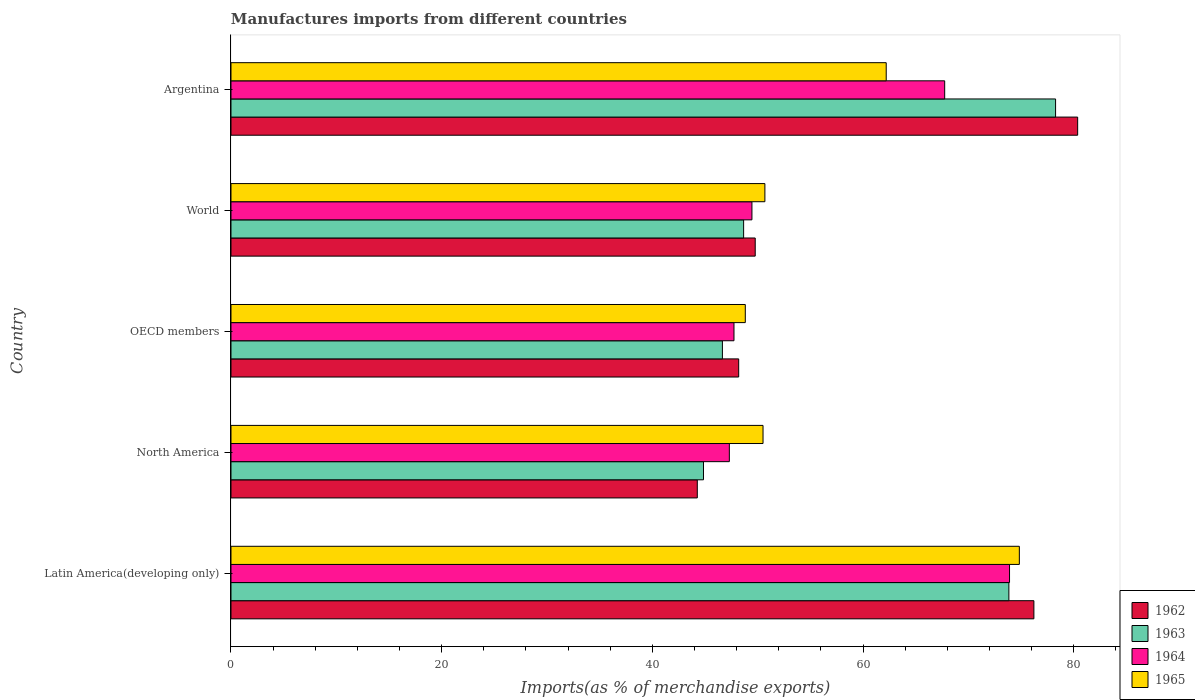How many different coloured bars are there?
Provide a short and direct response. 4. How many groups of bars are there?
Keep it short and to the point. 5. Are the number of bars per tick equal to the number of legend labels?
Your answer should be very brief. Yes. What is the label of the 2nd group of bars from the top?
Your answer should be compact. World. In how many cases, is the number of bars for a given country not equal to the number of legend labels?
Ensure brevity in your answer.  0. What is the percentage of imports to different countries in 1963 in North America?
Keep it short and to the point. 44.85. Across all countries, what is the maximum percentage of imports to different countries in 1964?
Your answer should be compact. 73.9. Across all countries, what is the minimum percentage of imports to different countries in 1962?
Your answer should be compact. 44.26. In which country was the percentage of imports to different countries in 1965 maximum?
Provide a succinct answer. Latin America(developing only). In which country was the percentage of imports to different countries in 1962 minimum?
Your response must be concise. North America. What is the total percentage of imports to different countries in 1964 in the graph?
Offer a terse response. 286.14. What is the difference between the percentage of imports to different countries in 1964 in Argentina and that in Latin America(developing only)?
Provide a short and direct response. -6.16. What is the difference between the percentage of imports to different countries in 1964 in Latin America(developing only) and the percentage of imports to different countries in 1962 in World?
Your answer should be compact. 24.14. What is the average percentage of imports to different countries in 1963 per country?
Keep it short and to the point. 58.45. What is the difference between the percentage of imports to different countries in 1965 and percentage of imports to different countries in 1964 in Latin America(developing only)?
Give a very brief answer. 0.93. What is the ratio of the percentage of imports to different countries in 1962 in Argentina to that in North America?
Offer a very short reply. 1.82. Is the difference between the percentage of imports to different countries in 1965 in Argentina and OECD members greater than the difference between the percentage of imports to different countries in 1964 in Argentina and OECD members?
Provide a succinct answer. No. What is the difference between the highest and the second highest percentage of imports to different countries in 1964?
Make the answer very short. 6.16. What is the difference between the highest and the lowest percentage of imports to different countries in 1962?
Offer a very short reply. 36.1. Is it the case that in every country, the sum of the percentage of imports to different countries in 1965 and percentage of imports to different countries in 1964 is greater than the sum of percentage of imports to different countries in 1962 and percentage of imports to different countries in 1963?
Your answer should be compact. No. What does the 4th bar from the top in North America represents?
Your response must be concise. 1962. What does the 2nd bar from the bottom in Latin America(developing only) represents?
Your answer should be compact. 1963. Are the values on the major ticks of X-axis written in scientific E-notation?
Keep it short and to the point. No. Does the graph contain grids?
Your answer should be compact. No. How are the legend labels stacked?
Your answer should be compact. Vertical. What is the title of the graph?
Offer a terse response. Manufactures imports from different countries. What is the label or title of the X-axis?
Give a very brief answer. Imports(as % of merchandise exports). What is the Imports(as % of merchandise exports) of 1962 in Latin America(developing only)?
Offer a very short reply. 76.21. What is the Imports(as % of merchandise exports) in 1963 in Latin America(developing only)?
Your answer should be compact. 73.84. What is the Imports(as % of merchandise exports) in 1964 in Latin America(developing only)?
Offer a very short reply. 73.9. What is the Imports(as % of merchandise exports) in 1965 in Latin America(developing only)?
Provide a succinct answer. 74.83. What is the Imports(as % of merchandise exports) of 1962 in North America?
Your answer should be compact. 44.26. What is the Imports(as % of merchandise exports) of 1963 in North America?
Provide a succinct answer. 44.85. What is the Imports(as % of merchandise exports) of 1964 in North America?
Keep it short and to the point. 47.3. What is the Imports(as % of merchandise exports) of 1965 in North America?
Give a very brief answer. 50.5. What is the Imports(as % of merchandise exports) in 1962 in OECD members?
Give a very brief answer. 48.19. What is the Imports(as % of merchandise exports) of 1963 in OECD members?
Provide a succinct answer. 46.65. What is the Imports(as % of merchandise exports) in 1964 in OECD members?
Make the answer very short. 47.75. What is the Imports(as % of merchandise exports) in 1965 in OECD members?
Your answer should be very brief. 48.82. What is the Imports(as % of merchandise exports) of 1962 in World?
Ensure brevity in your answer.  49.76. What is the Imports(as % of merchandise exports) of 1963 in World?
Keep it short and to the point. 48.66. What is the Imports(as % of merchandise exports) in 1964 in World?
Provide a succinct answer. 49.45. What is the Imports(as % of merchandise exports) in 1965 in World?
Your answer should be compact. 50.68. What is the Imports(as % of merchandise exports) in 1962 in Argentina?
Ensure brevity in your answer.  80.37. What is the Imports(as % of merchandise exports) in 1963 in Argentina?
Offer a terse response. 78.27. What is the Imports(as % of merchandise exports) of 1964 in Argentina?
Ensure brevity in your answer.  67.75. What is the Imports(as % of merchandise exports) of 1965 in Argentina?
Provide a succinct answer. 62.19. Across all countries, what is the maximum Imports(as % of merchandise exports) in 1962?
Provide a short and direct response. 80.37. Across all countries, what is the maximum Imports(as % of merchandise exports) in 1963?
Offer a terse response. 78.27. Across all countries, what is the maximum Imports(as % of merchandise exports) in 1964?
Your answer should be compact. 73.9. Across all countries, what is the maximum Imports(as % of merchandise exports) in 1965?
Your answer should be very brief. 74.83. Across all countries, what is the minimum Imports(as % of merchandise exports) in 1962?
Make the answer very short. 44.26. Across all countries, what is the minimum Imports(as % of merchandise exports) in 1963?
Your answer should be compact. 44.85. Across all countries, what is the minimum Imports(as % of merchandise exports) in 1964?
Your answer should be very brief. 47.3. Across all countries, what is the minimum Imports(as % of merchandise exports) in 1965?
Make the answer very short. 48.82. What is the total Imports(as % of merchandise exports) of 1962 in the graph?
Your answer should be compact. 298.79. What is the total Imports(as % of merchandise exports) of 1963 in the graph?
Your answer should be very brief. 292.26. What is the total Imports(as % of merchandise exports) in 1964 in the graph?
Your answer should be very brief. 286.14. What is the total Imports(as % of merchandise exports) in 1965 in the graph?
Your response must be concise. 287.03. What is the difference between the Imports(as % of merchandise exports) in 1962 in Latin America(developing only) and that in North America?
Offer a very short reply. 31.95. What is the difference between the Imports(as % of merchandise exports) in 1963 in Latin America(developing only) and that in North America?
Ensure brevity in your answer.  28.99. What is the difference between the Imports(as % of merchandise exports) in 1964 in Latin America(developing only) and that in North America?
Provide a short and direct response. 26.6. What is the difference between the Imports(as % of merchandise exports) in 1965 in Latin America(developing only) and that in North America?
Offer a terse response. 24.33. What is the difference between the Imports(as % of merchandise exports) in 1962 in Latin America(developing only) and that in OECD members?
Your answer should be very brief. 28.02. What is the difference between the Imports(as % of merchandise exports) of 1963 in Latin America(developing only) and that in OECD members?
Your response must be concise. 27.19. What is the difference between the Imports(as % of merchandise exports) in 1964 in Latin America(developing only) and that in OECD members?
Offer a very short reply. 26.16. What is the difference between the Imports(as % of merchandise exports) of 1965 in Latin America(developing only) and that in OECD members?
Ensure brevity in your answer.  26.01. What is the difference between the Imports(as % of merchandise exports) of 1962 in Latin America(developing only) and that in World?
Your response must be concise. 26.45. What is the difference between the Imports(as % of merchandise exports) of 1963 in Latin America(developing only) and that in World?
Ensure brevity in your answer.  25.18. What is the difference between the Imports(as % of merchandise exports) of 1964 in Latin America(developing only) and that in World?
Provide a short and direct response. 24.45. What is the difference between the Imports(as % of merchandise exports) in 1965 in Latin America(developing only) and that in World?
Provide a short and direct response. 24.15. What is the difference between the Imports(as % of merchandise exports) in 1962 in Latin America(developing only) and that in Argentina?
Provide a short and direct response. -4.15. What is the difference between the Imports(as % of merchandise exports) in 1963 in Latin America(developing only) and that in Argentina?
Provide a short and direct response. -4.43. What is the difference between the Imports(as % of merchandise exports) of 1964 in Latin America(developing only) and that in Argentina?
Make the answer very short. 6.16. What is the difference between the Imports(as % of merchandise exports) in 1965 in Latin America(developing only) and that in Argentina?
Keep it short and to the point. 12.64. What is the difference between the Imports(as % of merchandise exports) of 1962 in North America and that in OECD members?
Make the answer very short. -3.93. What is the difference between the Imports(as % of merchandise exports) in 1963 in North America and that in OECD members?
Make the answer very short. -1.8. What is the difference between the Imports(as % of merchandise exports) in 1964 in North America and that in OECD members?
Give a very brief answer. -0.44. What is the difference between the Imports(as % of merchandise exports) of 1965 in North America and that in OECD members?
Keep it short and to the point. 1.68. What is the difference between the Imports(as % of merchandise exports) of 1962 in North America and that in World?
Keep it short and to the point. -5.5. What is the difference between the Imports(as % of merchandise exports) in 1963 in North America and that in World?
Provide a succinct answer. -3.81. What is the difference between the Imports(as % of merchandise exports) in 1964 in North America and that in World?
Provide a succinct answer. -2.14. What is the difference between the Imports(as % of merchandise exports) of 1965 in North America and that in World?
Your answer should be very brief. -0.18. What is the difference between the Imports(as % of merchandise exports) of 1962 in North America and that in Argentina?
Your answer should be very brief. -36.1. What is the difference between the Imports(as % of merchandise exports) in 1963 in North America and that in Argentina?
Keep it short and to the point. -33.42. What is the difference between the Imports(as % of merchandise exports) in 1964 in North America and that in Argentina?
Give a very brief answer. -20.44. What is the difference between the Imports(as % of merchandise exports) in 1965 in North America and that in Argentina?
Provide a succinct answer. -11.69. What is the difference between the Imports(as % of merchandise exports) in 1962 in OECD members and that in World?
Your answer should be compact. -1.57. What is the difference between the Imports(as % of merchandise exports) in 1963 in OECD members and that in World?
Make the answer very short. -2.01. What is the difference between the Imports(as % of merchandise exports) of 1964 in OECD members and that in World?
Keep it short and to the point. -1.7. What is the difference between the Imports(as % of merchandise exports) in 1965 in OECD members and that in World?
Your answer should be compact. -1.86. What is the difference between the Imports(as % of merchandise exports) in 1962 in OECD members and that in Argentina?
Your answer should be compact. -32.17. What is the difference between the Imports(as % of merchandise exports) of 1963 in OECD members and that in Argentina?
Your response must be concise. -31.62. What is the difference between the Imports(as % of merchandise exports) in 1964 in OECD members and that in Argentina?
Provide a succinct answer. -20. What is the difference between the Imports(as % of merchandise exports) in 1965 in OECD members and that in Argentina?
Keep it short and to the point. -13.38. What is the difference between the Imports(as % of merchandise exports) in 1962 in World and that in Argentina?
Your answer should be compact. -30.61. What is the difference between the Imports(as % of merchandise exports) of 1963 in World and that in Argentina?
Offer a very short reply. -29.61. What is the difference between the Imports(as % of merchandise exports) of 1964 in World and that in Argentina?
Provide a succinct answer. -18.3. What is the difference between the Imports(as % of merchandise exports) in 1965 in World and that in Argentina?
Ensure brevity in your answer.  -11.52. What is the difference between the Imports(as % of merchandise exports) in 1962 in Latin America(developing only) and the Imports(as % of merchandise exports) in 1963 in North America?
Provide a succinct answer. 31.36. What is the difference between the Imports(as % of merchandise exports) in 1962 in Latin America(developing only) and the Imports(as % of merchandise exports) in 1964 in North America?
Offer a very short reply. 28.91. What is the difference between the Imports(as % of merchandise exports) in 1962 in Latin America(developing only) and the Imports(as % of merchandise exports) in 1965 in North America?
Provide a succinct answer. 25.71. What is the difference between the Imports(as % of merchandise exports) in 1963 in Latin America(developing only) and the Imports(as % of merchandise exports) in 1964 in North America?
Make the answer very short. 26.53. What is the difference between the Imports(as % of merchandise exports) of 1963 in Latin America(developing only) and the Imports(as % of merchandise exports) of 1965 in North America?
Ensure brevity in your answer.  23.34. What is the difference between the Imports(as % of merchandise exports) in 1964 in Latin America(developing only) and the Imports(as % of merchandise exports) in 1965 in North America?
Offer a very short reply. 23.4. What is the difference between the Imports(as % of merchandise exports) in 1962 in Latin America(developing only) and the Imports(as % of merchandise exports) in 1963 in OECD members?
Your answer should be very brief. 29.57. What is the difference between the Imports(as % of merchandise exports) in 1962 in Latin America(developing only) and the Imports(as % of merchandise exports) in 1964 in OECD members?
Give a very brief answer. 28.47. What is the difference between the Imports(as % of merchandise exports) in 1962 in Latin America(developing only) and the Imports(as % of merchandise exports) in 1965 in OECD members?
Ensure brevity in your answer.  27.39. What is the difference between the Imports(as % of merchandise exports) in 1963 in Latin America(developing only) and the Imports(as % of merchandise exports) in 1964 in OECD members?
Offer a very short reply. 26.09. What is the difference between the Imports(as % of merchandise exports) in 1963 in Latin America(developing only) and the Imports(as % of merchandise exports) in 1965 in OECD members?
Make the answer very short. 25.02. What is the difference between the Imports(as % of merchandise exports) in 1964 in Latin America(developing only) and the Imports(as % of merchandise exports) in 1965 in OECD members?
Keep it short and to the point. 25.08. What is the difference between the Imports(as % of merchandise exports) of 1962 in Latin America(developing only) and the Imports(as % of merchandise exports) of 1963 in World?
Your answer should be compact. 27.55. What is the difference between the Imports(as % of merchandise exports) in 1962 in Latin America(developing only) and the Imports(as % of merchandise exports) in 1964 in World?
Offer a very short reply. 26.76. What is the difference between the Imports(as % of merchandise exports) of 1962 in Latin America(developing only) and the Imports(as % of merchandise exports) of 1965 in World?
Provide a succinct answer. 25.53. What is the difference between the Imports(as % of merchandise exports) of 1963 in Latin America(developing only) and the Imports(as % of merchandise exports) of 1964 in World?
Give a very brief answer. 24.39. What is the difference between the Imports(as % of merchandise exports) of 1963 in Latin America(developing only) and the Imports(as % of merchandise exports) of 1965 in World?
Make the answer very short. 23.16. What is the difference between the Imports(as % of merchandise exports) of 1964 in Latin America(developing only) and the Imports(as % of merchandise exports) of 1965 in World?
Ensure brevity in your answer.  23.22. What is the difference between the Imports(as % of merchandise exports) in 1962 in Latin America(developing only) and the Imports(as % of merchandise exports) in 1963 in Argentina?
Provide a succinct answer. -2.06. What is the difference between the Imports(as % of merchandise exports) in 1962 in Latin America(developing only) and the Imports(as % of merchandise exports) in 1964 in Argentina?
Your response must be concise. 8.47. What is the difference between the Imports(as % of merchandise exports) in 1962 in Latin America(developing only) and the Imports(as % of merchandise exports) in 1965 in Argentina?
Offer a very short reply. 14.02. What is the difference between the Imports(as % of merchandise exports) in 1963 in Latin America(developing only) and the Imports(as % of merchandise exports) in 1964 in Argentina?
Provide a succinct answer. 6.09. What is the difference between the Imports(as % of merchandise exports) in 1963 in Latin America(developing only) and the Imports(as % of merchandise exports) in 1965 in Argentina?
Offer a very short reply. 11.64. What is the difference between the Imports(as % of merchandise exports) in 1964 in Latin America(developing only) and the Imports(as % of merchandise exports) in 1965 in Argentina?
Provide a succinct answer. 11.71. What is the difference between the Imports(as % of merchandise exports) in 1962 in North America and the Imports(as % of merchandise exports) in 1963 in OECD members?
Make the answer very short. -2.38. What is the difference between the Imports(as % of merchandise exports) in 1962 in North America and the Imports(as % of merchandise exports) in 1964 in OECD members?
Give a very brief answer. -3.48. What is the difference between the Imports(as % of merchandise exports) of 1962 in North America and the Imports(as % of merchandise exports) of 1965 in OECD members?
Your answer should be very brief. -4.56. What is the difference between the Imports(as % of merchandise exports) in 1963 in North America and the Imports(as % of merchandise exports) in 1964 in OECD members?
Provide a short and direct response. -2.89. What is the difference between the Imports(as % of merchandise exports) in 1963 in North America and the Imports(as % of merchandise exports) in 1965 in OECD members?
Offer a very short reply. -3.97. What is the difference between the Imports(as % of merchandise exports) of 1964 in North America and the Imports(as % of merchandise exports) of 1965 in OECD members?
Provide a short and direct response. -1.52. What is the difference between the Imports(as % of merchandise exports) of 1962 in North America and the Imports(as % of merchandise exports) of 1963 in World?
Provide a short and direct response. -4.4. What is the difference between the Imports(as % of merchandise exports) in 1962 in North America and the Imports(as % of merchandise exports) in 1964 in World?
Provide a short and direct response. -5.19. What is the difference between the Imports(as % of merchandise exports) in 1962 in North America and the Imports(as % of merchandise exports) in 1965 in World?
Make the answer very short. -6.42. What is the difference between the Imports(as % of merchandise exports) of 1963 in North America and the Imports(as % of merchandise exports) of 1964 in World?
Make the answer very short. -4.6. What is the difference between the Imports(as % of merchandise exports) in 1963 in North America and the Imports(as % of merchandise exports) in 1965 in World?
Offer a terse response. -5.83. What is the difference between the Imports(as % of merchandise exports) in 1964 in North America and the Imports(as % of merchandise exports) in 1965 in World?
Offer a very short reply. -3.37. What is the difference between the Imports(as % of merchandise exports) of 1962 in North America and the Imports(as % of merchandise exports) of 1963 in Argentina?
Ensure brevity in your answer.  -34.01. What is the difference between the Imports(as % of merchandise exports) of 1962 in North America and the Imports(as % of merchandise exports) of 1964 in Argentina?
Provide a succinct answer. -23.48. What is the difference between the Imports(as % of merchandise exports) in 1962 in North America and the Imports(as % of merchandise exports) in 1965 in Argentina?
Your answer should be compact. -17.93. What is the difference between the Imports(as % of merchandise exports) in 1963 in North America and the Imports(as % of merchandise exports) in 1964 in Argentina?
Offer a terse response. -22.89. What is the difference between the Imports(as % of merchandise exports) of 1963 in North America and the Imports(as % of merchandise exports) of 1965 in Argentina?
Your response must be concise. -17.34. What is the difference between the Imports(as % of merchandise exports) of 1964 in North America and the Imports(as % of merchandise exports) of 1965 in Argentina?
Give a very brief answer. -14.89. What is the difference between the Imports(as % of merchandise exports) of 1962 in OECD members and the Imports(as % of merchandise exports) of 1963 in World?
Make the answer very short. -0.47. What is the difference between the Imports(as % of merchandise exports) in 1962 in OECD members and the Imports(as % of merchandise exports) in 1964 in World?
Make the answer very short. -1.26. What is the difference between the Imports(as % of merchandise exports) of 1962 in OECD members and the Imports(as % of merchandise exports) of 1965 in World?
Your answer should be compact. -2.49. What is the difference between the Imports(as % of merchandise exports) of 1963 in OECD members and the Imports(as % of merchandise exports) of 1964 in World?
Offer a terse response. -2.8. What is the difference between the Imports(as % of merchandise exports) of 1963 in OECD members and the Imports(as % of merchandise exports) of 1965 in World?
Keep it short and to the point. -4.03. What is the difference between the Imports(as % of merchandise exports) in 1964 in OECD members and the Imports(as % of merchandise exports) in 1965 in World?
Ensure brevity in your answer.  -2.93. What is the difference between the Imports(as % of merchandise exports) of 1962 in OECD members and the Imports(as % of merchandise exports) of 1963 in Argentina?
Ensure brevity in your answer.  -30.08. What is the difference between the Imports(as % of merchandise exports) in 1962 in OECD members and the Imports(as % of merchandise exports) in 1964 in Argentina?
Provide a short and direct response. -19.55. What is the difference between the Imports(as % of merchandise exports) of 1962 in OECD members and the Imports(as % of merchandise exports) of 1965 in Argentina?
Offer a terse response. -14. What is the difference between the Imports(as % of merchandise exports) in 1963 in OECD members and the Imports(as % of merchandise exports) in 1964 in Argentina?
Offer a very short reply. -21.1. What is the difference between the Imports(as % of merchandise exports) in 1963 in OECD members and the Imports(as % of merchandise exports) in 1965 in Argentina?
Provide a succinct answer. -15.55. What is the difference between the Imports(as % of merchandise exports) of 1964 in OECD members and the Imports(as % of merchandise exports) of 1965 in Argentina?
Your answer should be very brief. -14.45. What is the difference between the Imports(as % of merchandise exports) in 1962 in World and the Imports(as % of merchandise exports) in 1963 in Argentina?
Your response must be concise. -28.51. What is the difference between the Imports(as % of merchandise exports) of 1962 in World and the Imports(as % of merchandise exports) of 1964 in Argentina?
Your response must be concise. -17.98. What is the difference between the Imports(as % of merchandise exports) in 1962 in World and the Imports(as % of merchandise exports) in 1965 in Argentina?
Keep it short and to the point. -12.43. What is the difference between the Imports(as % of merchandise exports) of 1963 in World and the Imports(as % of merchandise exports) of 1964 in Argentina?
Make the answer very short. -19.09. What is the difference between the Imports(as % of merchandise exports) of 1963 in World and the Imports(as % of merchandise exports) of 1965 in Argentina?
Offer a very short reply. -13.54. What is the difference between the Imports(as % of merchandise exports) of 1964 in World and the Imports(as % of merchandise exports) of 1965 in Argentina?
Provide a succinct answer. -12.75. What is the average Imports(as % of merchandise exports) of 1962 per country?
Your response must be concise. 59.76. What is the average Imports(as % of merchandise exports) in 1963 per country?
Your response must be concise. 58.45. What is the average Imports(as % of merchandise exports) of 1964 per country?
Your response must be concise. 57.23. What is the average Imports(as % of merchandise exports) of 1965 per country?
Ensure brevity in your answer.  57.41. What is the difference between the Imports(as % of merchandise exports) in 1962 and Imports(as % of merchandise exports) in 1963 in Latin America(developing only)?
Make the answer very short. 2.37. What is the difference between the Imports(as % of merchandise exports) of 1962 and Imports(as % of merchandise exports) of 1964 in Latin America(developing only)?
Provide a succinct answer. 2.31. What is the difference between the Imports(as % of merchandise exports) in 1962 and Imports(as % of merchandise exports) in 1965 in Latin America(developing only)?
Ensure brevity in your answer.  1.38. What is the difference between the Imports(as % of merchandise exports) in 1963 and Imports(as % of merchandise exports) in 1964 in Latin America(developing only)?
Ensure brevity in your answer.  -0.06. What is the difference between the Imports(as % of merchandise exports) in 1963 and Imports(as % of merchandise exports) in 1965 in Latin America(developing only)?
Keep it short and to the point. -0.99. What is the difference between the Imports(as % of merchandise exports) of 1964 and Imports(as % of merchandise exports) of 1965 in Latin America(developing only)?
Ensure brevity in your answer.  -0.93. What is the difference between the Imports(as % of merchandise exports) of 1962 and Imports(as % of merchandise exports) of 1963 in North America?
Give a very brief answer. -0.59. What is the difference between the Imports(as % of merchandise exports) in 1962 and Imports(as % of merchandise exports) in 1964 in North America?
Give a very brief answer. -3.04. What is the difference between the Imports(as % of merchandise exports) of 1962 and Imports(as % of merchandise exports) of 1965 in North America?
Keep it short and to the point. -6.24. What is the difference between the Imports(as % of merchandise exports) of 1963 and Imports(as % of merchandise exports) of 1964 in North America?
Give a very brief answer. -2.45. What is the difference between the Imports(as % of merchandise exports) of 1963 and Imports(as % of merchandise exports) of 1965 in North America?
Offer a terse response. -5.65. What is the difference between the Imports(as % of merchandise exports) of 1964 and Imports(as % of merchandise exports) of 1965 in North America?
Provide a succinct answer. -3.2. What is the difference between the Imports(as % of merchandise exports) of 1962 and Imports(as % of merchandise exports) of 1963 in OECD members?
Your response must be concise. 1.55. What is the difference between the Imports(as % of merchandise exports) in 1962 and Imports(as % of merchandise exports) in 1964 in OECD members?
Provide a short and direct response. 0.45. What is the difference between the Imports(as % of merchandise exports) of 1962 and Imports(as % of merchandise exports) of 1965 in OECD members?
Make the answer very short. -0.63. What is the difference between the Imports(as % of merchandise exports) of 1963 and Imports(as % of merchandise exports) of 1964 in OECD members?
Provide a succinct answer. -1.1. What is the difference between the Imports(as % of merchandise exports) in 1963 and Imports(as % of merchandise exports) in 1965 in OECD members?
Ensure brevity in your answer.  -2.17. What is the difference between the Imports(as % of merchandise exports) of 1964 and Imports(as % of merchandise exports) of 1965 in OECD members?
Provide a succinct answer. -1.07. What is the difference between the Imports(as % of merchandise exports) of 1962 and Imports(as % of merchandise exports) of 1963 in World?
Give a very brief answer. 1.1. What is the difference between the Imports(as % of merchandise exports) of 1962 and Imports(as % of merchandise exports) of 1964 in World?
Make the answer very short. 0.31. What is the difference between the Imports(as % of merchandise exports) in 1962 and Imports(as % of merchandise exports) in 1965 in World?
Your answer should be very brief. -0.92. What is the difference between the Imports(as % of merchandise exports) in 1963 and Imports(as % of merchandise exports) in 1964 in World?
Provide a succinct answer. -0.79. What is the difference between the Imports(as % of merchandise exports) of 1963 and Imports(as % of merchandise exports) of 1965 in World?
Your response must be concise. -2.02. What is the difference between the Imports(as % of merchandise exports) of 1964 and Imports(as % of merchandise exports) of 1965 in World?
Keep it short and to the point. -1.23. What is the difference between the Imports(as % of merchandise exports) in 1962 and Imports(as % of merchandise exports) in 1963 in Argentina?
Offer a very short reply. 2.1. What is the difference between the Imports(as % of merchandise exports) in 1962 and Imports(as % of merchandise exports) in 1964 in Argentina?
Give a very brief answer. 12.62. What is the difference between the Imports(as % of merchandise exports) of 1962 and Imports(as % of merchandise exports) of 1965 in Argentina?
Provide a succinct answer. 18.17. What is the difference between the Imports(as % of merchandise exports) of 1963 and Imports(as % of merchandise exports) of 1964 in Argentina?
Give a very brief answer. 10.52. What is the difference between the Imports(as % of merchandise exports) of 1963 and Imports(as % of merchandise exports) of 1965 in Argentina?
Your answer should be compact. 16.08. What is the difference between the Imports(as % of merchandise exports) in 1964 and Imports(as % of merchandise exports) in 1965 in Argentina?
Offer a terse response. 5.55. What is the ratio of the Imports(as % of merchandise exports) in 1962 in Latin America(developing only) to that in North America?
Make the answer very short. 1.72. What is the ratio of the Imports(as % of merchandise exports) in 1963 in Latin America(developing only) to that in North America?
Give a very brief answer. 1.65. What is the ratio of the Imports(as % of merchandise exports) in 1964 in Latin America(developing only) to that in North America?
Provide a short and direct response. 1.56. What is the ratio of the Imports(as % of merchandise exports) of 1965 in Latin America(developing only) to that in North America?
Ensure brevity in your answer.  1.48. What is the ratio of the Imports(as % of merchandise exports) of 1962 in Latin America(developing only) to that in OECD members?
Your response must be concise. 1.58. What is the ratio of the Imports(as % of merchandise exports) in 1963 in Latin America(developing only) to that in OECD members?
Provide a succinct answer. 1.58. What is the ratio of the Imports(as % of merchandise exports) in 1964 in Latin America(developing only) to that in OECD members?
Keep it short and to the point. 1.55. What is the ratio of the Imports(as % of merchandise exports) in 1965 in Latin America(developing only) to that in OECD members?
Keep it short and to the point. 1.53. What is the ratio of the Imports(as % of merchandise exports) in 1962 in Latin America(developing only) to that in World?
Ensure brevity in your answer.  1.53. What is the ratio of the Imports(as % of merchandise exports) of 1963 in Latin America(developing only) to that in World?
Your answer should be very brief. 1.52. What is the ratio of the Imports(as % of merchandise exports) in 1964 in Latin America(developing only) to that in World?
Provide a succinct answer. 1.49. What is the ratio of the Imports(as % of merchandise exports) of 1965 in Latin America(developing only) to that in World?
Provide a succinct answer. 1.48. What is the ratio of the Imports(as % of merchandise exports) of 1962 in Latin America(developing only) to that in Argentina?
Offer a terse response. 0.95. What is the ratio of the Imports(as % of merchandise exports) of 1963 in Latin America(developing only) to that in Argentina?
Offer a terse response. 0.94. What is the ratio of the Imports(as % of merchandise exports) in 1965 in Latin America(developing only) to that in Argentina?
Provide a short and direct response. 1.2. What is the ratio of the Imports(as % of merchandise exports) in 1962 in North America to that in OECD members?
Keep it short and to the point. 0.92. What is the ratio of the Imports(as % of merchandise exports) of 1963 in North America to that in OECD members?
Your answer should be compact. 0.96. What is the ratio of the Imports(as % of merchandise exports) of 1964 in North America to that in OECD members?
Your response must be concise. 0.99. What is the ratio of the Imports(as % of merchandise exports) of 1965 in North America to that in OECD members?
Keep it short and to the point. 1.03. What is the ratio of the Imports(as % of merchandise exports) in 1962 in North America to that in World?
Your response must be concise. 0.89. What is the ratio of the Imports(as % of merchandise exports) in 1963 in North America to that in World?
Ensure brevity in your answer.  0.92. What is the ratio of the Imports(as % of merchandise exports) in 1964 in North America to that in World?
Make the answer very short. 0.96. What is the ratio of the Imports(as % of merchandise exports) in 1962 in North America to that in Argentina?
Give a very brief answer. 0.55. What is the ratio of the Imports(as % of merchandise exports) of 1963 in North America to that in Argentina?
Provide a succinct answer. 0.57. What is the ratio of the Imports(as % of merchandise exports) of 1964 in North America to that in Argentina?
Keep it short and to the point. 0.7. What is the ratio of the Imports(as % of merchandise exports) in 1965 in North America to that in Argentina?
Provide a short and direct response. 0.81. What is the ratio of the Imports(as % of merchandise exports) of 1962 in OECD members to that in World?
Provide a short and direct response. 0.97. What is the ratio of the Imports(as % of merchandise exports) of 1963 in OECD members to that in World?
Ensure brevity in your answer.  0.96. What is the ratio of the Imports(as % of merchandise exports) in 1964 in OECD members to that in World?
Make the answer very short. 0.97. What is the ratio of the Imports(as % of merchandise exports) in 1965 in OECD members to that in World?
Offer a very short reply. 0.96. What is the ratio of the Imports(as % of merchandise exports) in 1962 in OECD members to that in Argentina?
Keep it short and to the point. 0.6. What is the ratio of the Imports(as % of merchandise exports) of 1963 in OECD members to that in Argentina?
Your answer should be very brief. 0.6. What is the ratio of the Imports(as % of merchandise exports) of 1964 in OECD members to that in Argentina?
Make the answer very short. 0.7. What is the ratio of the Imports(as % of merchandise exports) of 1965 in OECD members to that in Argentina?
Provide a succinct answer. 0.78. What is the ratio of the Imports(as % of merchandise exports) in 1962 in World to that in Argentina?
Your answer should be compact. 0.62. What is the ratio of the Imports(as % of merchandise exports) of 1963 in World to that in Argentina?
Provide a succinct answer. 0.62. What is the ratio of the Imports(as % of merchandise exports) of 1964 in World to that in Argentina?
Offer a very short reply. 0.73. What is the ratio of the Imports(as % of merchandise exports) in 1965 in World to that in Argentina?
Make the answer very short. 0.81. What is the difference between the highest and the second highest Imports(as % of merchandise exports) in 1962?
Give a very brief answer. 4.15. What is the difference between the highest and the second highest Imports(as % of merchandise exports) of 1963?
Ensure brevity in your answer.  4.43. What is the difference between the highest and the second highest Imports(as % of merchandise exports) in 1964?
Offer a very short reply. 6.16. What is the difference between the highest and the second highest Imports(as % of merchandise exports) of 1965?
Your response must be concise. 12.64. What is the difference between the highest and the lowest Imports(as % of merchandise exports) of 1962?
Your answer should be compact. 36.1. What is the difference between the highest and the lowest Imports(as % of merchandise exports) in 1963?
Your answer should be very brief. 33.42. What is the difference between the highest and the lowest Imports(as % of merchandise exports) in 1964?
Offer a terse response. 26.6. What is the difference between the highest and the lowest Imports(as % of merchandise exports) in 1965?
Your answer should be very brief. 26.01. 